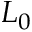<formula> <loc_0><loc_0><loc_500><loc_500>L _ { 0 }</formula> 